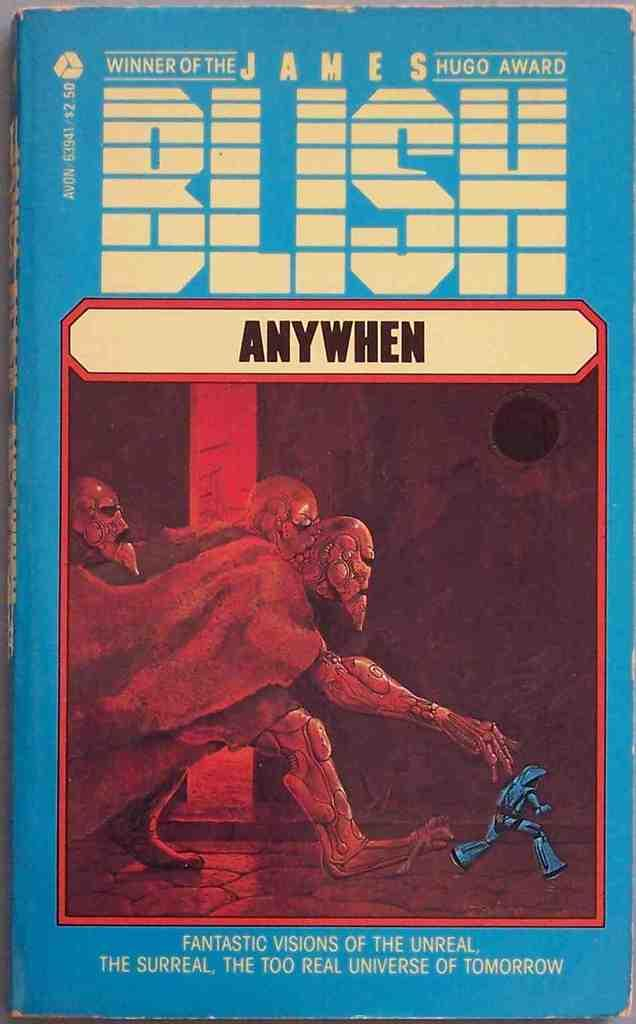<image>
Render a clear and concise summary of the photo. a blue book with the word blish on it 